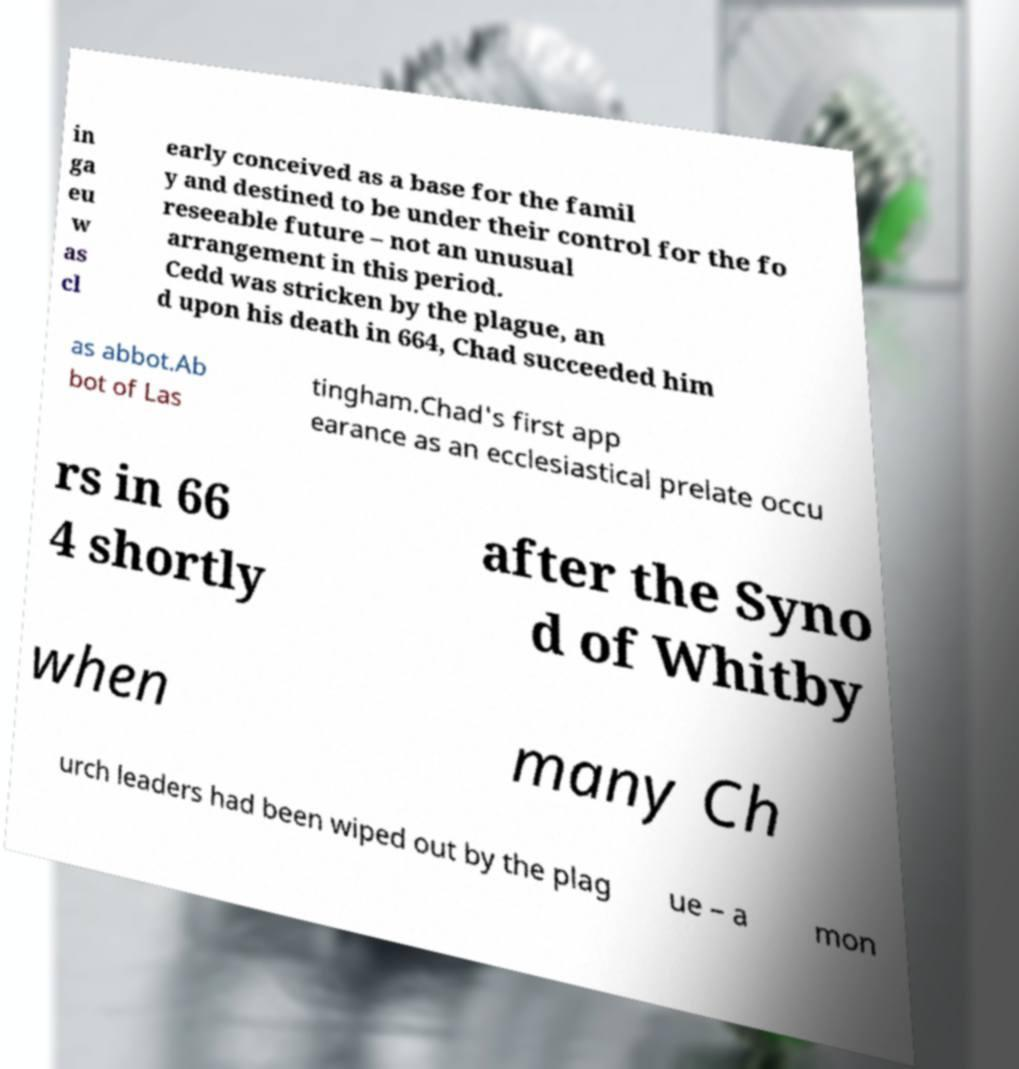Could you assist in decoding the text presented in this image and type it out clearly? in ga eu w as cl early conceived as a base for the famil y and destined to be under their control for the fo reseeable future – not an unusual arrangement in this period. Cedd was stricken by the plague, an d upon his death in 664, Chad succeeded him as abbot.Ab bot of Las tingham.Chad's first app earance as an ecclesiastical prelate occu rs in 66 4 shortly after the Syno d of Whitby when many Ch urch leaders had been wiped out by the plag ue – a mon 